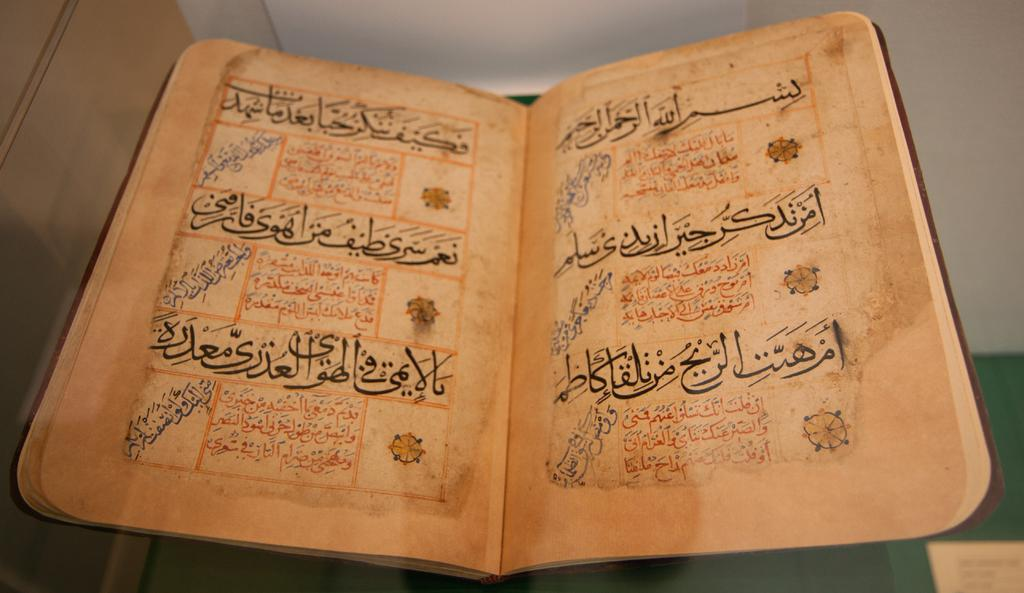<image>
Create a compact narrative representing the image presented. A book with Arabic calligraphy in black, red, and blue ink. 